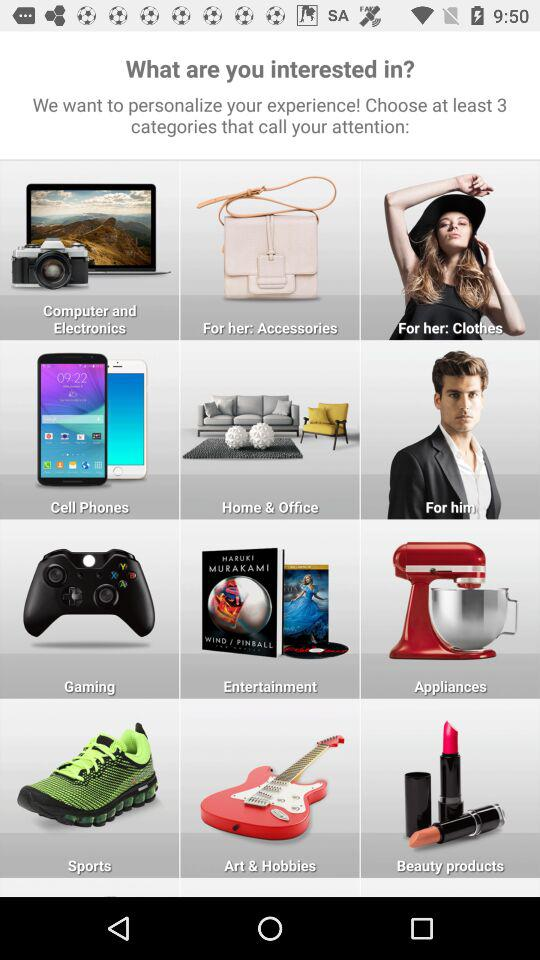Which categories are chosen?
When the provided information is insufficient, respond with <no answer>. <no answer> 